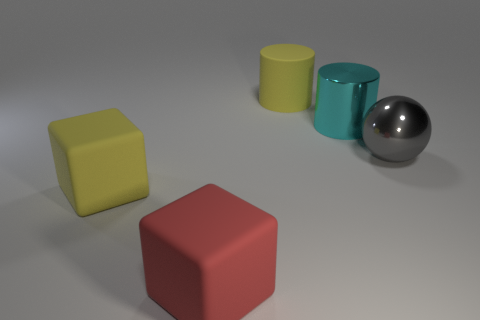Add 1 tiny purple metal objects. How many objects exist? 6 Subtract all spheres. How many objects are left? 4 Subtract all red objects. Subtract all shiny spheres. How many objects are left? 3 Add 2 big yellow objects. How many big yellow objects are left? 4 Add 1 metal cylinders. How many metal cylinders exist? 2 Subtract 0 blue blocks. How many objects are left? 5 